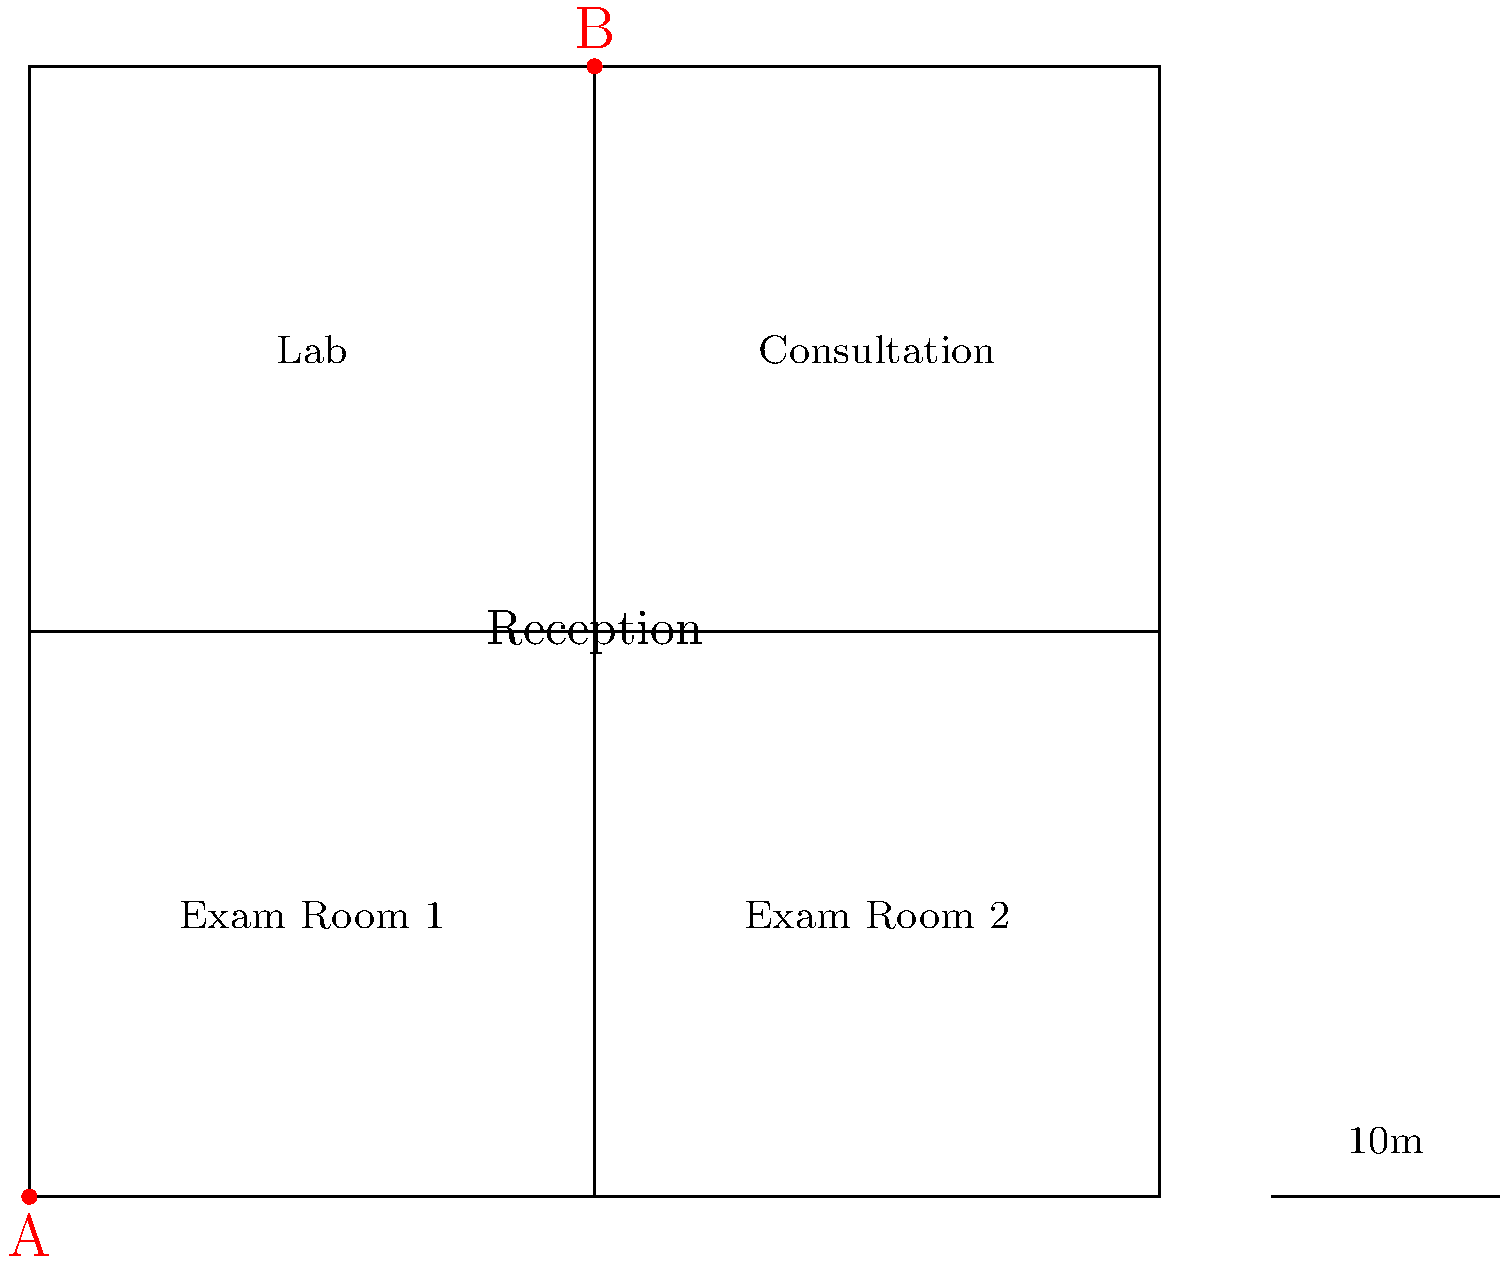In the floor plan of a fertility clinic, what is the approximate distance between point A (main entrance) and point B (center of the hallway leading to the lab and consultation room)? To estimate the distance between points A and B, we can follow these steps:

1. Observe that the floor plan is a square, and the given scale shows that 20 units on the diagram represent 10 meters.

2. The total width of the square is 100 units, which means:
   100 units = 50 meters (real-world distance)

3. Point A is at the bottom-left corner (0,0), and point B is at the center-top of the square (50,100).

4. This forms a right triangle with a base of 50 units and a height of 100 units.

5. We can use the Pythagorean theorem to calculate the distance:
   $$d = \sqrt{50^2 + 100^2}$$

6. Simplify:
   $$d = \sqrt{2500 + 10000} = \sqrt{12500} \approx 111.8$$ units

7. Convert to real-world distance:
   $$111.8 \times \frac{50}{100} \approx 55.9$$ meters

Therefore, the approximate distance between points A and B is about 56 meters.
Answer: 56 meters 